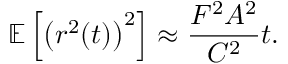<formula> <loc_0><loc_0><loc_500><loc_500>\mathbb { E } \left [ \left ( r ^ { 2 } ( t ) \right ) ^ { 2 } \right ] \approx \frac { F ^ { 2 } A ^ { 2 } } { C ^ { 2 } } t .</formula> 